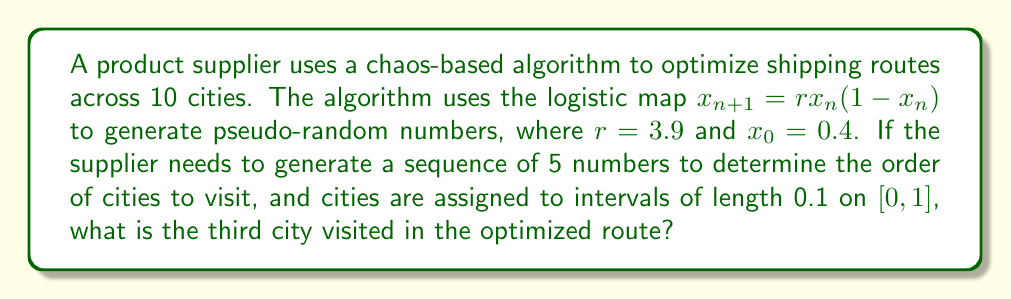Can you answer this question? To solve this problem, we need to follow these steps:

1) Use the logistic map equation to generate a sequence of 5 numbers:

   $x_{n+1} = rx_n(1-x_n)$, where $r=3.9$ and $x_0=0.4$

2) Calculate the first 5 iterations:

   $x_1 = 3.9 * 0.4 * (1-0.4) = 0.936$
   $x_2 = 3.9 * 0.936 * (1-0.936) = 0.234$
   $x_3 = 3.9 * 0.234 * (1-0.234) = 0.700$
   $x_4 = 3.9 * 0.700 * (1-0.700) = 0.819$
   $x_5 = 3.9 * 0.819 * (1-0.819) = 0.579$

3) The cities are assigned to intervals of length 0.1 on $[0,1]$. This means:
   City 1: $[0, 0.1)$
   City 2: $[0.1, 0.2)$
   City 3: $[0.2, 0.3)$
   ...
   City 10: $[0.9, 1)$

4) Match the generated numbers to the city intervals:
   $x_1 = 0.936$ corresponds to City 10
   $x_2 = 0.234$ corresponds to City 3
   $x_3 = 0.700$ corresponds to City 7
   $x_4 = 0.819$ corresponds to City 9
   $x_5 = 0.579$ corresponds to City 6

5) The question asks for the third city visited, which corresponds to $x_3 = 0.700$

Therefore, the third city visited in the optimized route is City 7.
Answer: City 7 